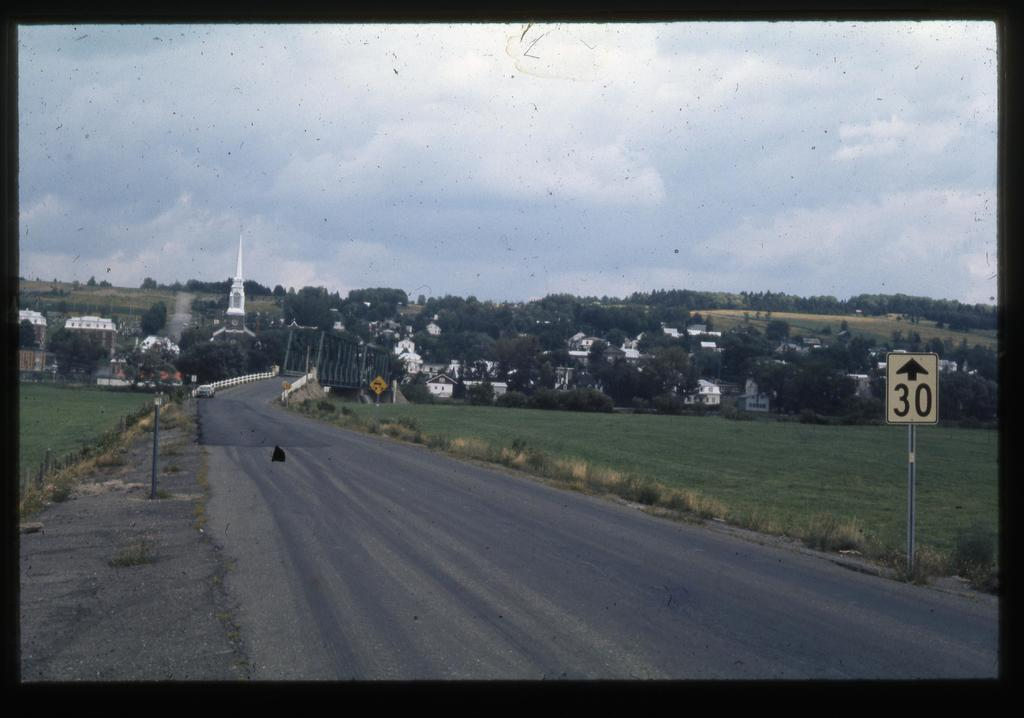What type of pathway is visible in the image? There is a road in the image. What structures can be seen alongside the road? There are poles, buildings, and trees visible in the image. Are there any informational or directional signs in the image? Yes, there are sign boards in the image. What can be seen in the background of the image? The sky is visible in the background of the image, and clouds are present in the sky. What type of growth can be seen on the toad in the image? There is no toad present in the image, so it is not possible to determine any growth on it. 